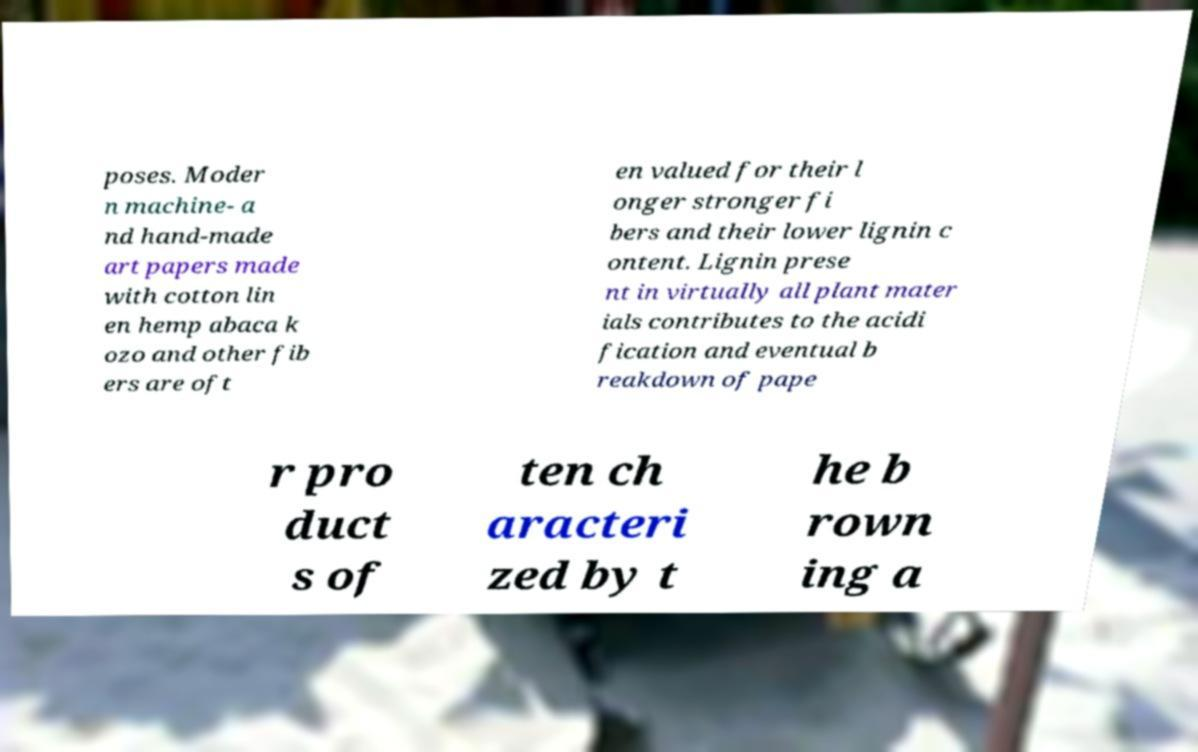Could you extract and type out the text from this image? poses. Moder n machine- a nd hand-made art papers made with cotton lin en hemp abaca k ozo and other fib ers are oft en valued for their l onger stronger fi bers and their lower lignin c ontent. Lignin prese nt in virtually all plant mater ials contributes to the acidi fication and eventual b reakdown of pape r pro duct s of ten ch aracteri zed by t he b rown ing a 